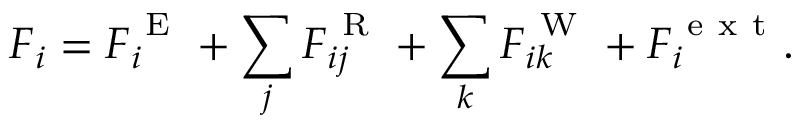Convert formula to latex. <formula><loc_0><loc_0><loc_500><loc_500>F _ { i } = F _ { i } ^ { E } + \sum _ { j } F _ { i j } ^ { R } + \sum _ { k } F _ { i k } ^ { W } + F _ { i } ^ { e x t } .</formula> 